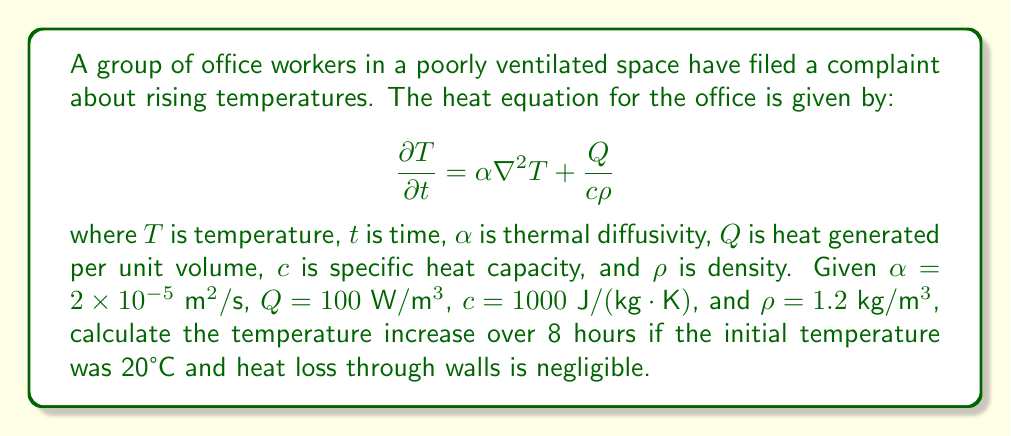Solve this math problem. To solve this problem, we'll follow these steps:

1) In a poorly ventilated space with negligible heat loss, we can assume the temperature change is uniform throughout the space. This simplifies our heat equation to:

   $$\frac{\partial T}{\partial t} = \frac{Q}{c\rho}$$

2) Integrate both sides with respect to time:

   $$\int_{T_0}^T dT = \int_0^t \frac{Q}{c\rho} dt$$

3) Solve the integral:

   $$T - T_0 = \frac{Q}{c\rho} t$$

4) Substitute the given values:
   $Q = 100 \text{ W}/\text{m}^3$
   $c = 1000 \text{ J}/(\text{kg}\cdot\text{K})$
   $\rho = 1.2 \text{ kg}/\text{m}^3$
   $t = 8 \text{ hours} = 28800 \text{ seconds}$
   $T_0 = 20°\text{C}$

   $$T - 20 = \frac{100}{1000 \cdot 1.2} \cdot 28800$$

5) Calculate the temperature change:

   $$\Delta T = T - 20 = 2400°\text{C}$$

6) Calculate the final temperature:

   $$T = 20 + 2400 = 2420°\text{C}$$

This unrealistically high temperature indicates that our assumption of negligible heat loss is invalid. In reality, heat would be lost through walls, windows, and ventilation, preventing such extreme temperatures.
Answer: 2420°C (unrealistic due to assumed negligible heat loss) 